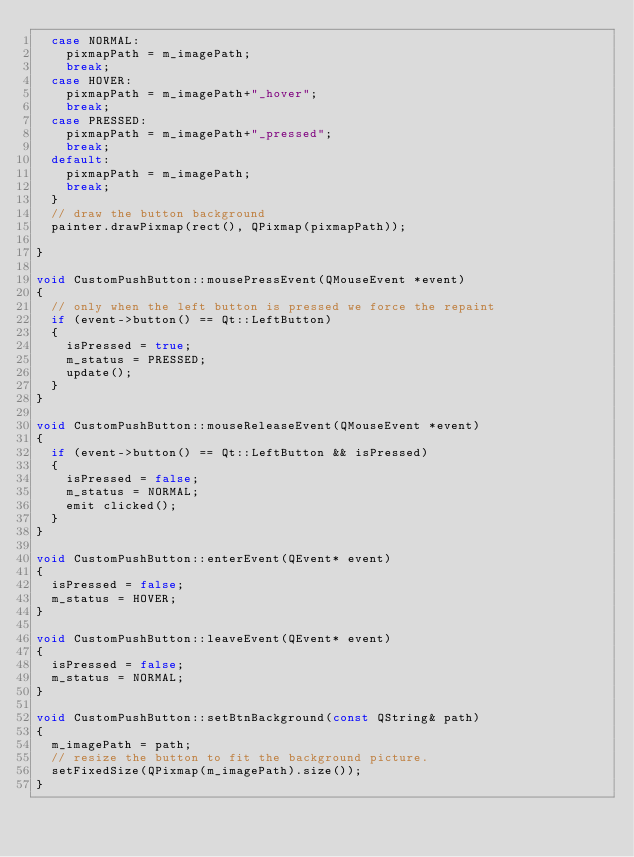<code> <loc_0><loc_0><loc_500><loc_500><_C++_>	case NORMAL:
		pixmapPath = m_imagePath;
		break;
	case HOVER:
		pixmapPath = m_imagePath+"_hover";
		break;
	case PRESSED:
		pixmapPath = m_imagePath+"_pressed";
		break;
	default:
		pixmapPath = m_imagePath;
		break;
	}
	// draw the button background
	painter.drawPixmap(rect(), QPixmap(pixmapPath));  

}

void CustomPushButton::mousePressEvent(QMouseEvent *event)
{
	// only when the left button is pressed we force the repaint
	if (event->button() == Qt::LeftButton)
	{
		isPressed = true;
		m_status = PRESSED;
		update();
	}
}

void CustomPushButton::mouseReleaseEvent(QMouseEvent *event)
{
	if (event->button() == Qt::LeftButton && isPressed)
	{
		isPressed = false;
		m_status = NORMAL;
		emit clicked();
	}
}

void CustomPushButton::enterEvent(QEvent* event)
{
	isPressed = false;
	m_status = HOVER;
}

void CustomPushButton::leaveEvent(QEvent* event)
{
	isPressed = false;
	m_status = NORMAL;
}

void CustomPushButton::setBtnBackground(const QString& path)
{
	m_imagePath = path;
	// resize the button to fit the background picture.
	setFixedSize(QPixmap(m_imagePath).size()); 
}</code> 